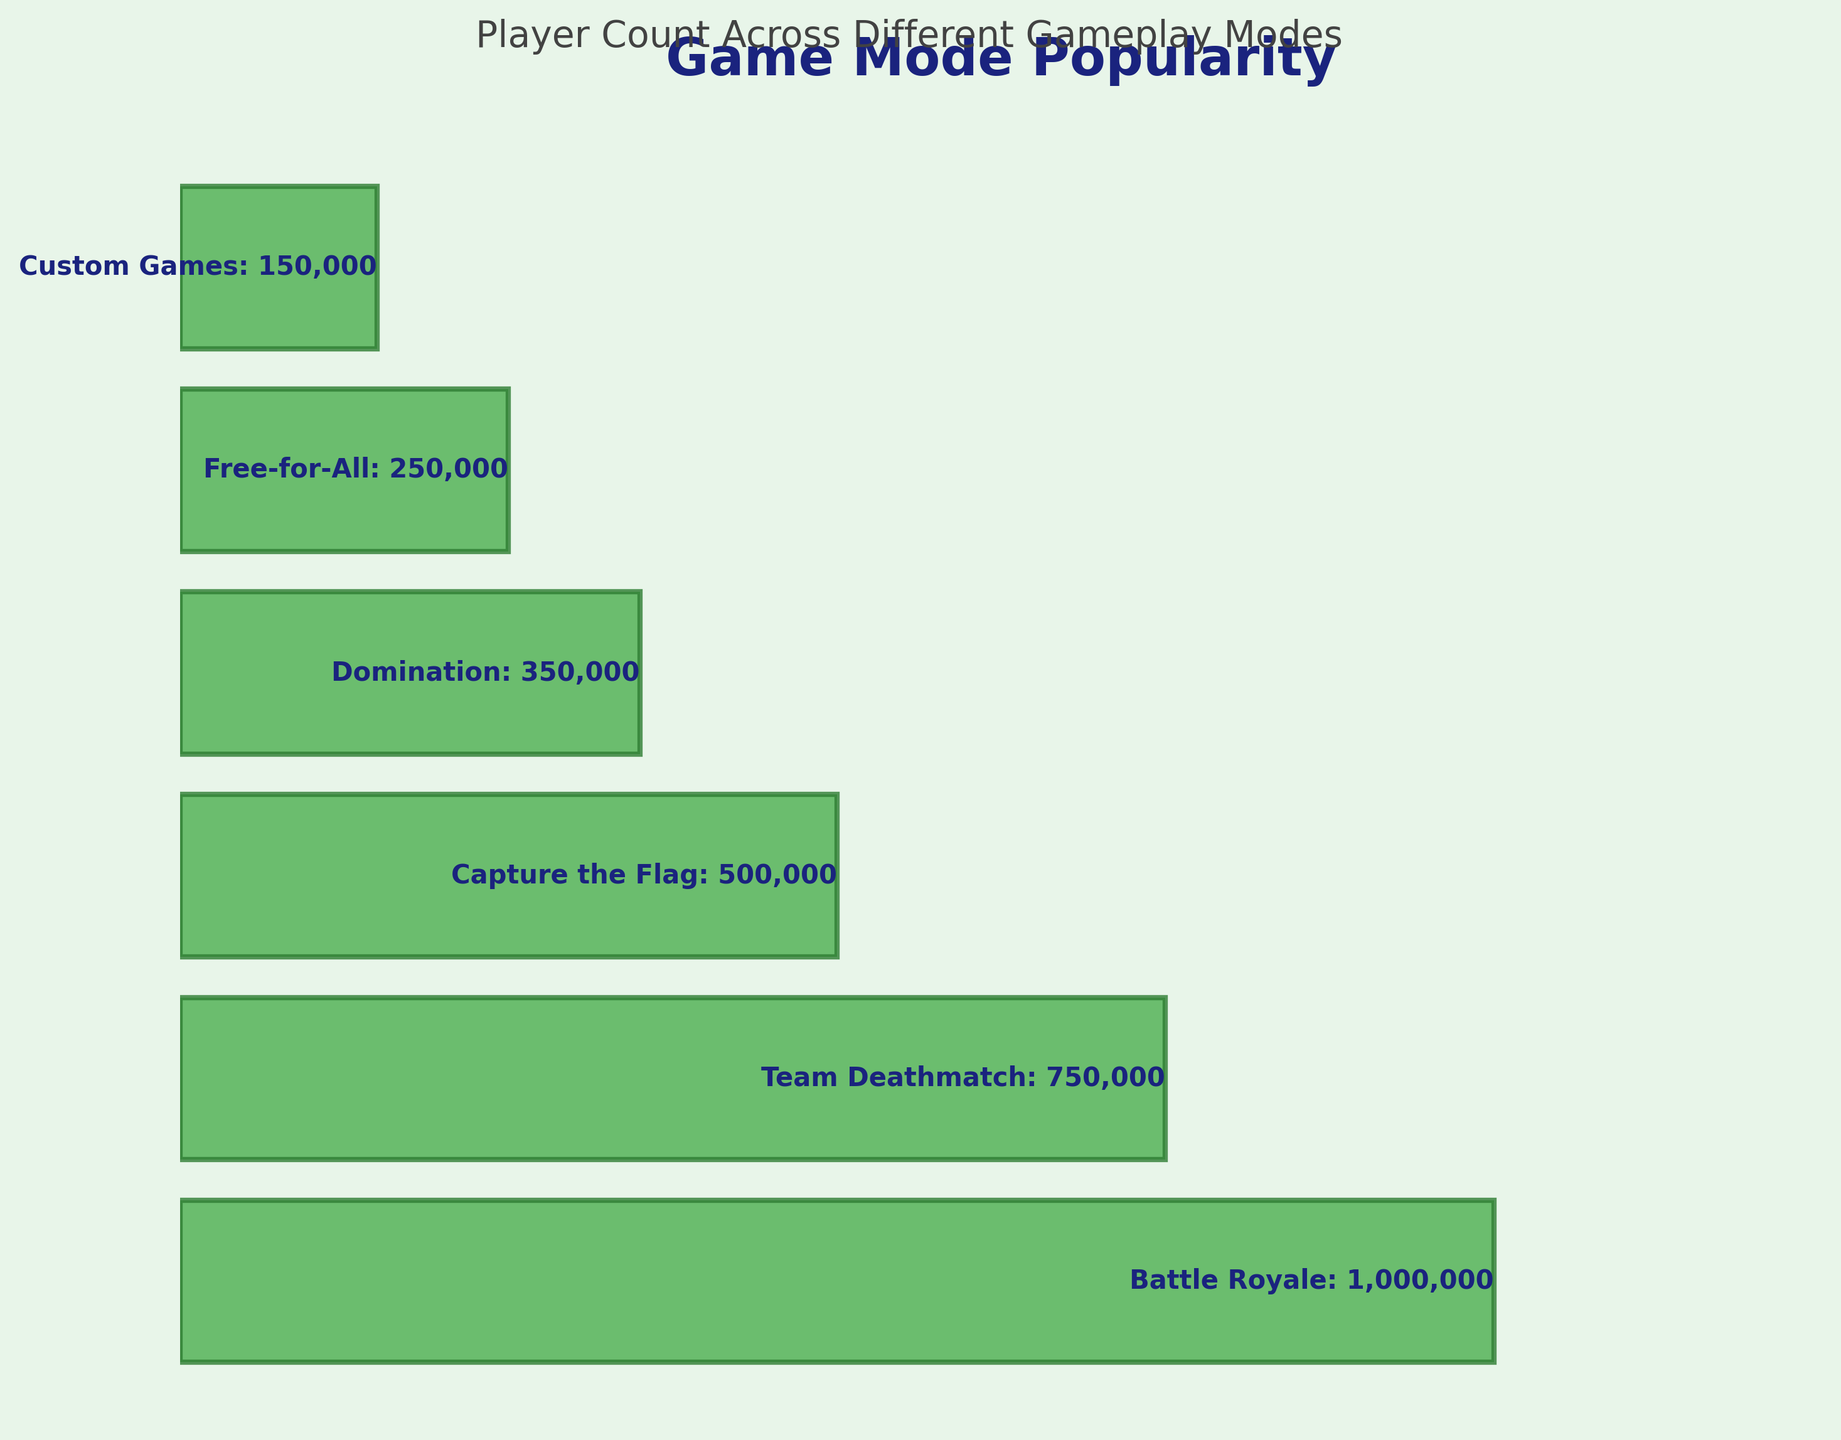What is the most popular game mode? The title indicates that the chart shows game mode popularity, and the widest bar at the top signifies "Battle Royale," with 1,000,000 players, making it the most popular.
Answer: Battle Royale How many players are there in the least popular game mode? The narrowest bar at the bottom represents "Custom Games." According to the label, it has 150,000 players.
Answer: 150,000 Which game mode has 250,000 players? The bar with exactly 250,000 players is labeled "Free-for-All."
Answer: Free-for-All What is the player difference between the most popular and the second most popular game modes? The most popular mode has 1,000,000 players (Battle Royale), and the second most popular has 750,000 players (Team Deathmatch). Subtracting these gives 1,000,000 - 750,000 = 250,000.
Answer: 250,000 How many players are there in total across all game modes? Add up the player counts for all game modes: 1,000,000 (Battle Royale) + 750,000 (Team Deathmatch) + 500,000 (Capture the Flag) + 350,000 (Domination) + 250,000 (Free-for-All) + 150,000 (Custom Games). The total is 3,000,000.
Answer: 3,000,000 Which game mode has 200,000 players more than "Domination"? "Domination" has 350,000 players. Adding 200,000 to this gives 550,000. The closest higher player count is 500,000, corresponding to "Capture the Flag."
Answer: Capture the Flag What is the difference in players between "Capture the Flag" and "Free-for-All"? "Capture the Flag" has 500,000 players, and "Free-for-All" has 250,000 players. Subtracting these gives 500,000 - 250,000 = 250,000.
Answer: 250,000 Which two game modes have a combined total of 1,000,000 players? "Capture the Flag" (500,000) + "Free-for-All" (250,000) + "Custom Games" (150,000) = 500,000 + 250,000 + 150,000 = 900,000, which is close but not precisely. Another combination does not fit the total exactly, so clarification may be needed.
Answer: None Rank the game modes from most to least popular. Arranging the game modes according to the width of the bars (player count) from largest to smallest: Battle Royale, Team Deathmatch, Capture the Flag, Domination, Free-for-All, Custom Games.
Answer: Battle Royale, Team Deathmatch, Capture the Flag, Domination, Free-for-All, Custom Games 